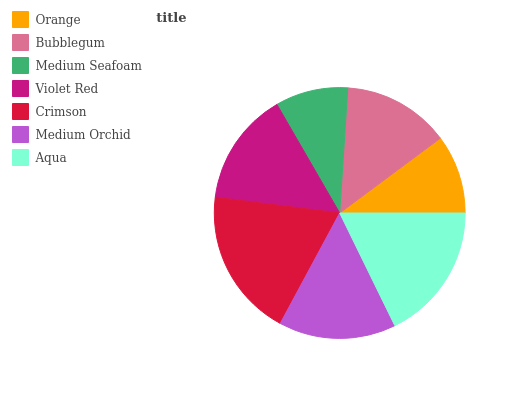Is Medium Seafoam the minimum?
Answer yes or no. Yes. Is Crimson the maximum?
Answer yes or no. Yes. Is Bubblegum the minimum?
Answer yes or no. No. Is Bubblegum the maximum?
Answer yes or no. No. Is Bubblegum greater than Orange?
Answer yes or no. Yes. Is Orange less than Bubblegum?
Answer yes or no. Yes. Is Orange greater than Bubblegum?
Answer yes or no. No. Is Bubblegum less than Orange?
Answer yes or no. No. Is Violet Red the high median?
Answer yes or no. Yes. Is Violet Red the low median?
Answer yes or no. Yes. Is Orange the high median?
Answer yes or no. No. Is Orange the low median?
Answer yes or no. No. 